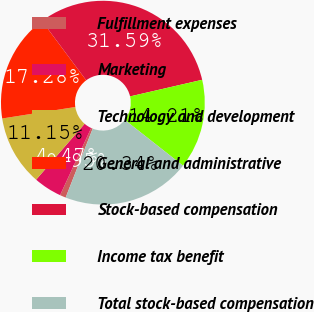Convert chart to OTSL. <chart><loc_0><loc_0><loc_500><loc_500><pie_chart><fcel>Fulfillment expenses<fcel>Marketing<fcel>Technology and development<fcel>General and administrative<fcel>Stock-based compensation<fcel>Income tax benefit<fcel>Total stock-based compensation<nl><fcel>0.95%<fcel>4.47%<fcel>11.15%<fcel>17.28%<fcel>31.59%<fcel>14.21%<fcel>20.34%<nl></chart> 